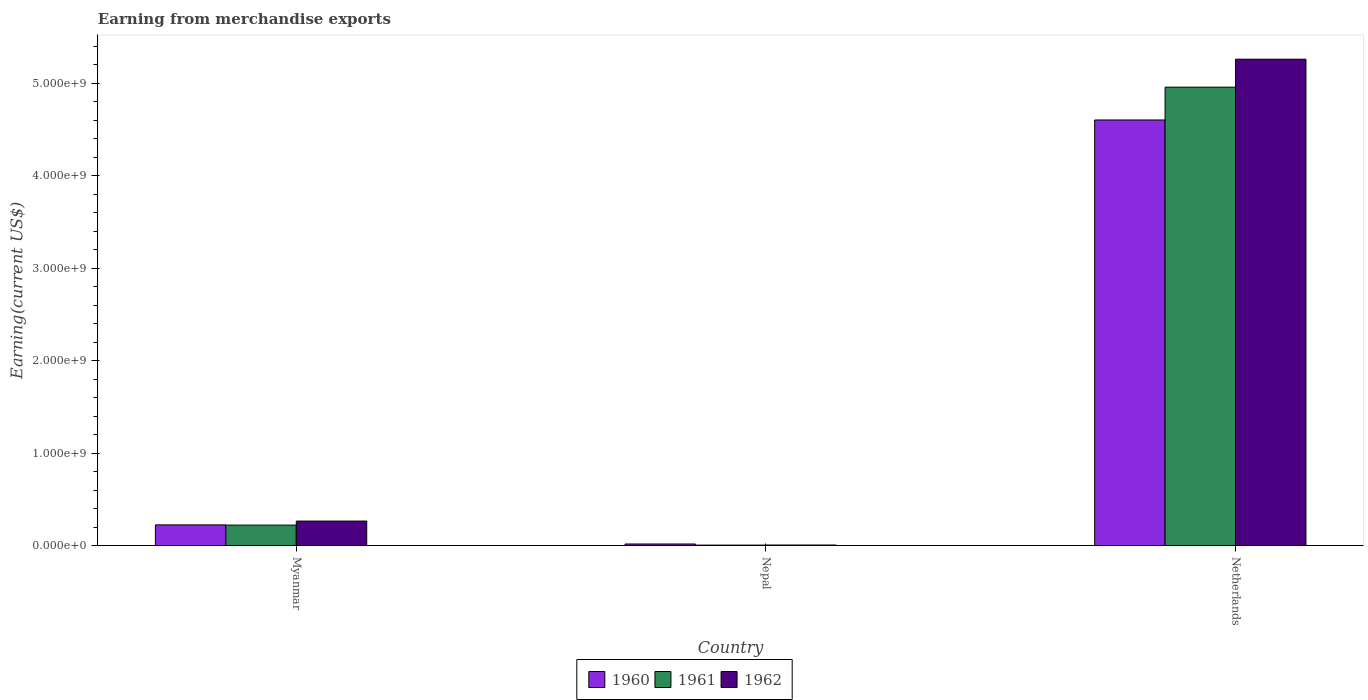How many bars are there on the 1st tick from the left?
Offer a very short reply. 3. How many bars are there on the 2nd tick from the right?
Give a very brief answer. 3. What is the label of the 1st group of bars from the left?
Ensure brevity in your answer.  Myanmar. In how many cases, is the number of bars for a given country not equal to the number of legend labels?
Your answer should be very brief. 0. What is the amount earned from merchandise exports in 1961 in Myanmar?
Provide a succinct answer. 2.21e+08. Across all countries, what is the maximum amount earned from merchandise exports in 1960?
Provide a succinct answer. 4.60e+09. Across all countries, what is the minimum amount earned from merchandise exports in 1961?
Offer a terse response. 5.00e+06. In which country was the amount earned from merchandise exports in 1962 minimum?
Offer a terse response. Nepal. What is the total amount earned from merchandise exports in 1961 in the graph?
Ensure brevity in your answer.  5.18e+09. What is the difference between the amount earned from merchandise exports in 1960 in Myanmar and that in Netherlands?
Your response must be concise. -4.38e+09. What is the difference between the amount earned from merchandise exports in 1960 in Netherlands and the amount earned from merchandise exports in 1962 in Myanmar?
Offer a very short reply. 4.34e+09. What is the average amount earned from merchandise exports in 1962 per country?
Make the answer very short. 1.84e+09. What is the difference between the amount earned from merchandise exports of/in 1960 and amount earned from merchandise exports of/in 1961 in Myanmar?
Make the answer very short. 2.42e+06. In how many countries, is the amount earned from merchandise exports in 1960 greater than 3800000000 US$?
Offer a terse response. 1. What is the ratio of the amount earned from merchandise exports in 1961 in Nepal to that in Netherlands?
Offer a terse response. 0. Is the amount earned from merchandise exports in 1960 in Nepal less than that in Netherlands?
Your answer should be very brief. Yes. Is the difference between the amount earned from merchandise exports in 1960 in Nepal and Netherlands greater than the difference between the amount earned from merchandise exports in 1961 in Nepal and Netherlands?
Ensure brevity in your answer.  Yes. What is the difference between the highest and the second highest amount earned from merchandise exports in 1961?
Your answer should be very brief. 4.95e+09. What is the difference between the highest and the lowest amount earned from merchandise exports in 1962?
Offer a terse response. 5.25e+09. In how many countries, is the amount earned from merchandise exports in 1960 greater than the average amount earned from merchandise exports in 1960 taken over all countries?
Provide a succinct answer. 1. Is the sum of the amount earned from merchandise exports in 1960 in Myanmar and Nepal greater than the maximum amount earned from merchandise exports in 1962 across all countries?
Your response must be concise. No. What does the 1st bar from the right in Myanmar represents?
Ensure brevity in your answer.  1962. Is it the case that in every country, the sum of the amount earned from merchandise exports in 1962 and amount earned from merchandise exports in 1961 is greater than the amount earned from merchandise exports in 1960?
Give a very brief answer. No. How many bars are there?
Provide a succinct answer. 9. What is the difference between two consecutive major ticks on the Y-axis?
Make the answer very short. 1.00e+09. Are the values on the major ticks of Y-axis written in scientific E-notation?
Make the answer very short. Yes. Does the graph contain any zero values?
Provide a succinct answer. No. Does the graph contain grids?
Make the answer very short. No. Where does the legend appear in the graph?
Offer a very short reply. Bottom center. How many legend labels are there?
Provide a short and direct response. 3. What is the title of the graph?
Your answer should be very brief. Earning from merchandise exports. Does "1977" appear as one of the legend labels in the graph?
Your answer should be compact. No. What is the label or title of the X-axis?
Your answer should be very brief. Country. What is the label or title of the Y-axis?
Ensure brevity in your answer.  Earning(current US$). What is the Earning(current US$) of 1960 in Myanmar?
Your answer should be very brief. 2.24e+08. What is the Earning(current US$) in 1961 in Myanmar?
Ensure brevity in your answer.  2.21e+08. What is the Earning(current US$) in 1962 in Myanmar?
Keep it short and to the point. 2.65e+08. What is the Earning(current US$) of 1960 in Nepal?
Your answer should be very brief. 1.70e+07. What is the Earning(current US$) of 1961 in Nepal?
Your answer should be very brief. 5.00e+06. What is the Earning(current US$) in 1962 in Nepal?
Make the answer very short. 6.00e+06. What is the Earning(current US$) of 1960 in Netherlands?
Make the answer very short. 4.60e+09. What is the Earning(current US$) in 1961 in Netherlands?
Keep it short and to the point. 4.96e+09. What is the Earning(current US$) of 1962 in Netherlands?
Provide a short and direct response. 5.26e+09. Across all countries, what is the maximum Earning(current US$) in 1960?
Ensure brevity in your answer.  4.60e+09. Across all countries, what is the maximum Earning(current US$) in 1961?
Give a very brief answer. 4.96e+09. Across all countries, what is the maximum Earning(current US$) of 1962?
Offer a very short reply. 5.26e+09. Across all countries, what is the minimum Earning(current US$) in 1960?
Your answer should be very brief. 1.70e+07. Across all countries, what is the minimum Earning(current US$) of 1962?
Provide a short and direct response. 6.00e+06. What is the total Earning(current US$) in 1960 in the graph?
Make the answer very short. 4.84e+09. What is the total Earning(current US$) in 1961 in the graph?
Keep it short and to the point. 5.18e+09. What is the total Earning(current US$) in 1962 in the graph?
Make the answer very short. 5.53e+09. What is the difference between the Earning(current US$) of 1960 in Myanmar and that in Nepal?
Your answer should be very brief. 2.07e+08. What is the difference between the Earning(current US$) in 1961 in Myanmar and that in Nepal?
Make the answer very short. 2.16e+08. What is the difference between the Earning(current US$) in 1962 in Myanmar and that in Nepal?
Your answer should be very brief. 2.59e+08. What is the difference between the Earning(current US$) of 1960 in Myanmar and that in Netherlands?
Give a very brief answer. -4.38e+09. What is the difference between the Earning(current US$) in 1961 in Myanmar and that in Netherlands?
Keep it short and to the point. -4.74e+09. What is the difference between the Earning(current US$) in 1962 in Myanmar and that in Netherlands?
Your answer should be very brief. -4.99e+09. What is the difference between the Earning(current US$) of 1960 in Nepal and that in Netherlands?
Keep it short and to the point. -4.59e+09. What is the difference between the Earning(current US$) in 1961 in Nepal and that in Netherlands?
Provide a short and direct response. -4.95e+09. What is the difference between the Earning(current US$) in 1962 in Nepal and that in Netherlands?
Provide a succinct answer. -5.25e+09. What is the difference between the Earning(current US$) in 1960 in Myanmar and the Earning(current US$) in 1961 in Nepal?
Keep it short and to the point. 2.19e+08. What is the difference between the Earning(current US$) in 1960 in Myanmar and the Earning(current US$) in 1962 in Nepal?
Your answer should be very brief. 2.18e+08. What is the difference between the Earning(current US$) in 1961 in Myanmar and the Earning(current US$) in 1962 in Nepal?
Provide a succinct answer. 2.15e+08. What is the difference between the Earning(current US$) in 1960 in Myanmar and the Earning(current US$) in 1961 in Netherlands?
Your answer should be compact. -4.73e+09. What is the difference between the Earning(current US$) in 1960 in Myanmar and the Earning(current US$) in 1962 in Netherlands?
Keep it short and to the point. -5.04e+09. What is the difference between the Earning(current US$) in 1961 in Myanmar and the Earning(current US$) in 1962 in Netherlands?
Provide a succinct answer. -5.04e+09. What is the difference between the Earning(current US$) in 1960 in Nepal and the Earning(current US$) in 1961 in Netherlands?
Keep it short and to the point. -4.94e+09. What is the difference between the Earning(current US$) in 1960 in Nepal and the Earning(current US$) in 1962 in Netherlands?
Your answer should be compact. -5.24e+09. What is the difference between the Earning(current US$) in 1961 in Nepal and the Earning(current US$) in 1962 in Netherlands?
Provide a succinct answer. -5.25e+09. What is the average Earning(current US$) of 1960 per country?
Offer a terse response. 1.61e+09. What is the average Earning(current US$) in 1961 per country?
Offer a terse response. 1.73e+09. What is the average Earning(current US$) in 1962 per country?
Your response must be concise. 1.84e+09. What is the difference between the Earning(current US$) of 1960 and Earning(current US$) of 1961 in Myanmar?
Provide a short and direct response. 2.42e+06. What is the difference between the Earning(current US$) of 1960 and Earning(current US$) of 1962 in Myanmar?
Provide a short and direct response. -4.11e+07. What is the difference between the Earning(current US$) in 1961 and Earning(current US$) in 1962 in Myanmar?
Give a very brief answer. -4.35e+07. What is the difference between the Earning(current US$) of 1960 and Earning(current US$) of 1962 in Nepal?
Your response must be concise. 1.10e+07. What is the difference between the Earning(current US$) of 1960 and Earning(current US$) of 1961 in Netherlands?
Your answer should be compact. -3.55e+08. What is the difference between the Earning(current US$) in 1960 and Earning(current US$) in 1962 in Netherlands?
Make the answer very short. -6.57e+08. What is the difference between the Earning(current US$) in 1961 and Earning(current US$) in 1962 in Netherlands?
Provide a short and direct response. -3.02e+08. What is the ratio of the Earning(current US$) in 1960 in Myanmar to that in Nepal?
Ensure brevity in your answer.  13.16. What is the ratio of the Earning(current US$) of 1961 in Myanmar to that in Nepal?
Provide a short and direct response. 44.27. What is the ratio of the Earning(current US$) in 1962 in Myanmar to that in Nepal?
Offer a terse response. 44.14. What is the ratio of the Earning(current US$) in 1960 in Myanmar to that in Netherlands?
Provide a succinct answer. 0.05. What is the ratio of the Earning(current US$) in 1961 in Myanmar to that in Netherlands?
Keep it short and to the point. 0.04. What is the ratio of the Earning(current US$) in 1962 in Myanmar to that in Netherlands?
Keep it short and to the point. 0.05. What is the ratio of the Earning(current US$) in 1960 in Nepal to that in Netherlands?
Your answer should be compact. 0. What is the ratio of the Earning(current US$) in 1961 in Nepal to that in Netherlands?
Offer a very short reply. 0. What is the ratio of the Earning(current US$) in 1962 in Nepal to that in Netherlands?
Offer a very short reply. 0. What is the difference between the highest and the second highest Earning(current US$) in 1960?
Give a very brief answer. 4.38e+09. What is the difference between the highest and the second highest Earning(current US$) in 1961?
Make the answer very short. 4.74e+09. What is the difference between the highest and the second highest Earning(current US$) of 1962?
Provide a short and direct response. 4.99e+09. What is the difference between the highest and the lowest Earning(current US$) of 1960?
Offer a terse response. 4.59e+09. What is the difference between the highest and the lowest Earning(current US$) of 1961?
Provide a short and direct response. 4.95e+09. What is the difference between the highest and the lowest Earning(current US$) in 1962?
Offer a terse response. 5.25e+09. 